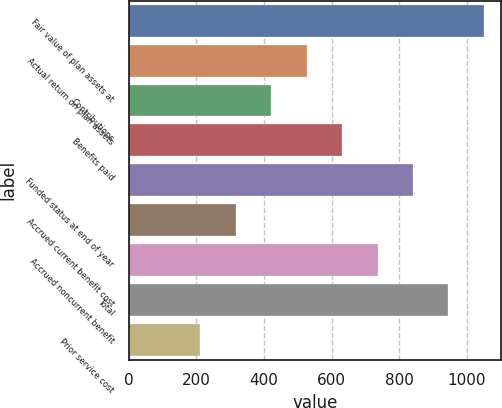Convert chart to OTSL. <chart><loc_0><loc_0><loc_500><loc_500><bar_chart><fcel>Fair value of plan assets at<fcel>Actual return on plan assets<fcel>Contributions<fcel>Benefits paid<fcel>Funded status at end of year<fcel>Accrued current benefit cost<fcel>Accrued noncurrent benefit<fcel>Total<fcel>Prior service cost<nl><fcel>1049.7<fcel>526.25<fcel>421.56<fcel>630.94<fcel>840.32<fcel>316.87<fcel>735.63<fcel>945.01<fcel>212.18<nl></chart> 